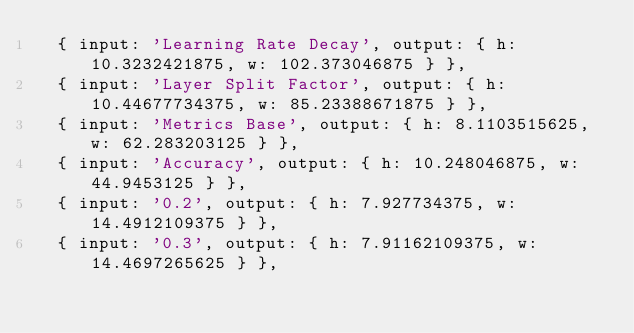<code> <loc_0><loc_0><loc_500><loc_500><_TypeScript_>  { input: 'Learning Rate Decay', output: { h: 10.3232421875, w: 102.373046875 } },
  { input: 'Layer Split Factor', output: { h: 10.44677734375, w: 85.23388671875 } },
  { input: 'Metrics Base', output: { h: 8.1103515625, w: 62.283203125 } },
  { input: 'Accuracy', output: { h: 10.248046875, w: 44.9453125 } },
  { input: '0.2', output: { h: 7.927734375, w: 14.4912109375 } },
  { input: '0.3', output: { h: 7.91162109375, w: 14.4697265625 } },</code> 